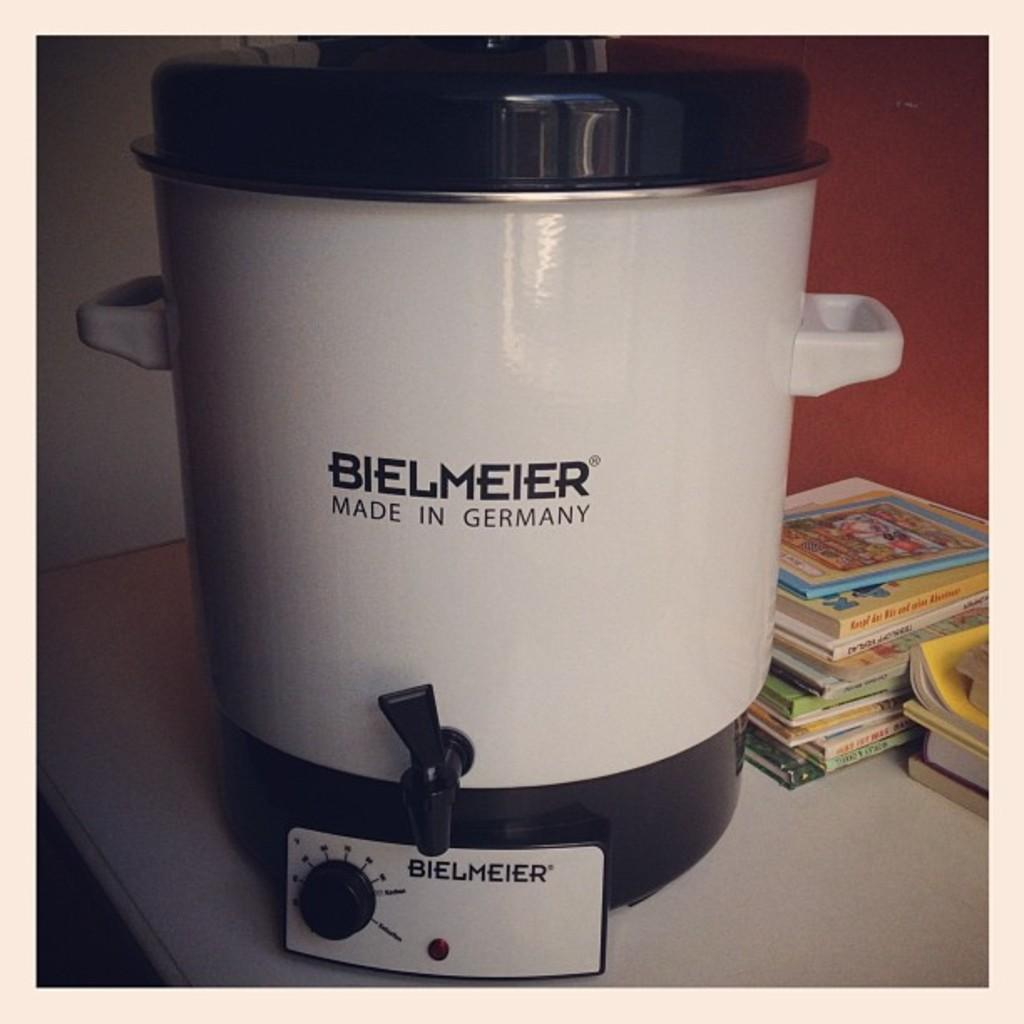<image>
Share a concise interpretation of the image provided. A Bielmeier product that was made in Germany 